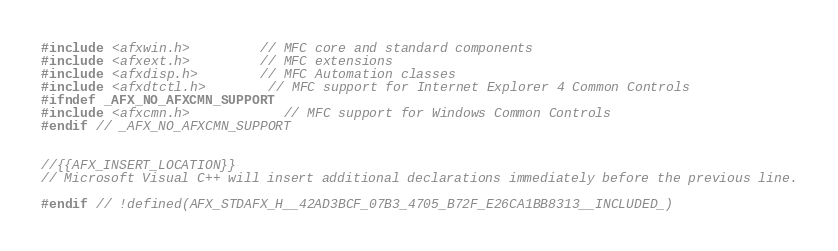<code> <loc_0><loc_0><loc_500><loc_500><_C_>#include <afxwin.h>         // MFC core and standard components
#include <afxext.h>         // MFC extensions
#include <afxdisp.h>        // MFC Automation classes
#include <afxdtctl.h>		// MFC support for Internet Explorer 4 Common Controls
#ifndef _AFX_NO_AFXCMN_SUPPORT
#include <afxcmn.h>			// MFC support for Windows Common Controls
#endif // _AFX_NO_AFXCMN_SUPPORT


//{{AFX_INSERT_LOCATION}}
// Microsoft Visual C++ will insert additional declarations immediately before the previous line.

#endif // !defined(AFX_STDAFX_H__42AD3BCF_07B3_4705_B72F_E26CA1BB8313__INCLUDED_)
</code> 